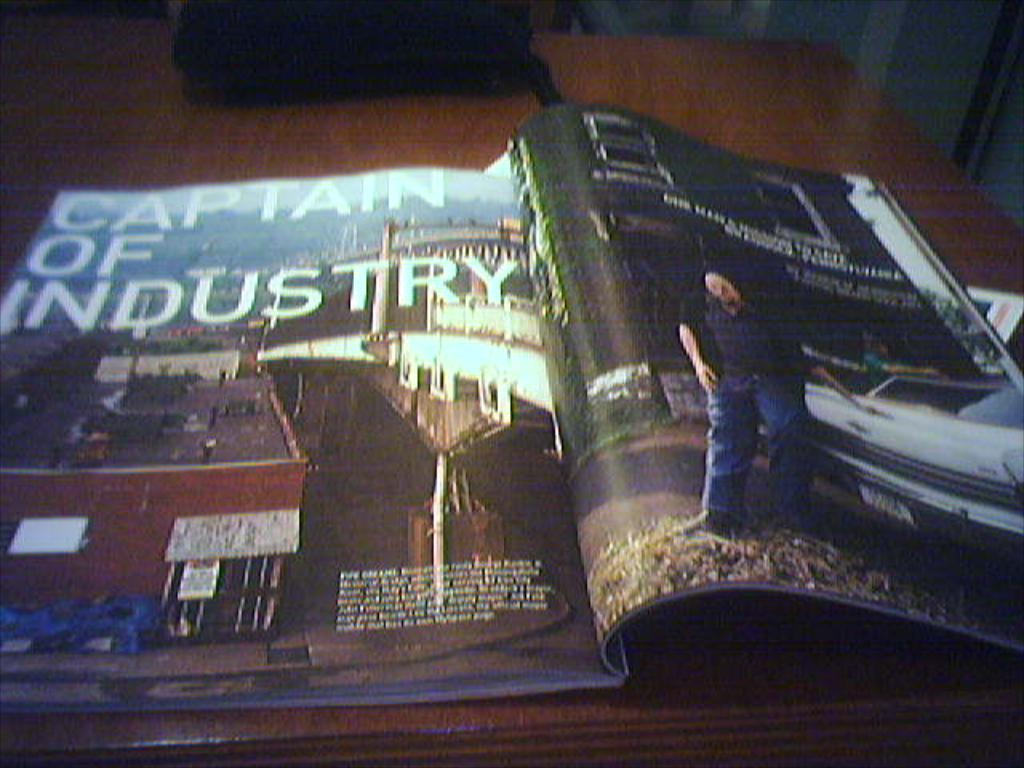<image>
Provide a brief description of the given image. A magazine open with a page headed "Captain of Industry". 